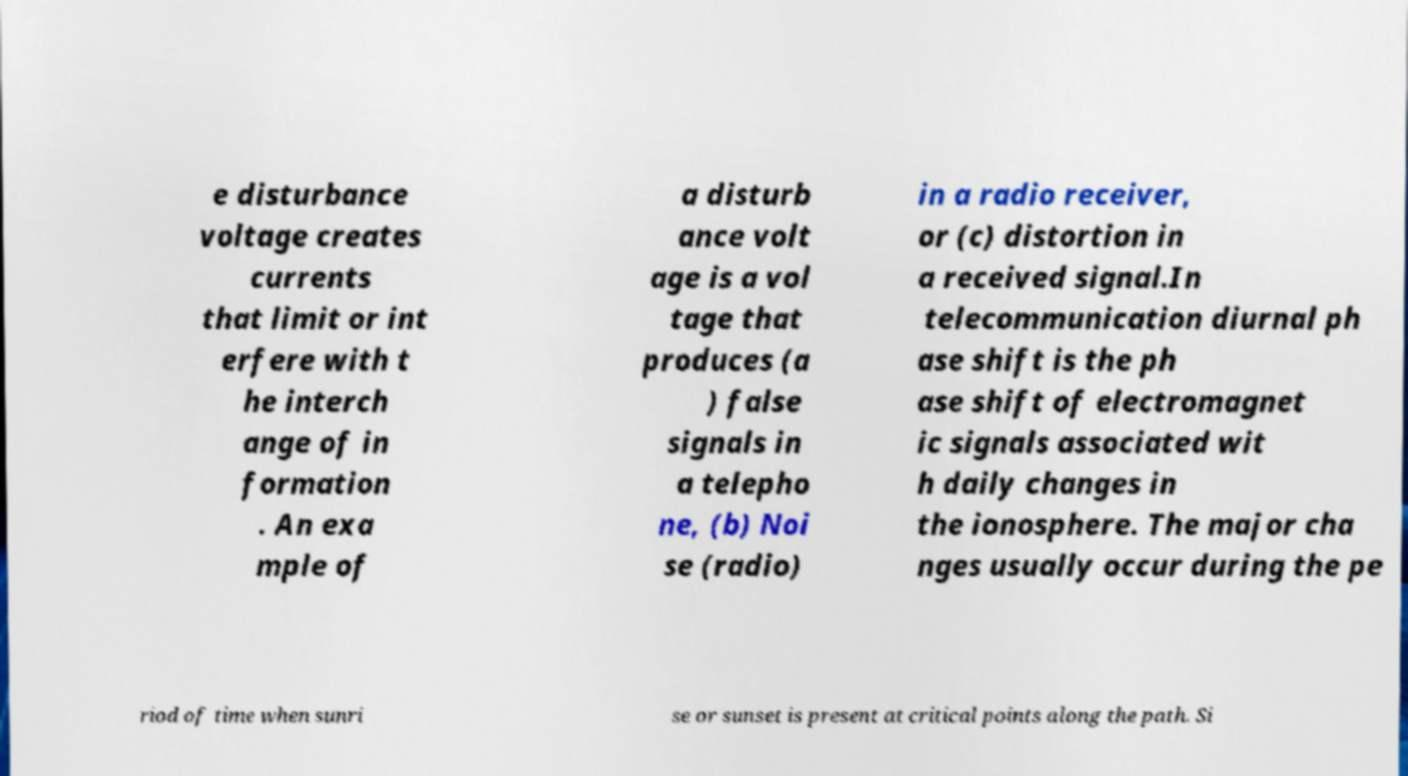For documentation purposes, I need the text within this image transcribed. Could you provide that? e disturbance voltage creates currents that limit or int erfere with t he interch ange of in formation . An exa mple of a disturb ance volt age is a vol tage that produces (a ) false signals in a telepho ne, (b) Noi se (radio) in a radio receiver, or (c) distortion in a received signal.In telecommunication diurnal ph ase shift is the ph ase shift of electromagnet ic signals associated wit h daily changes in the ionosphere. The major cha nges usually occur during the pe riod of time when sunri se or sunset is present at critical points along the path. Si 